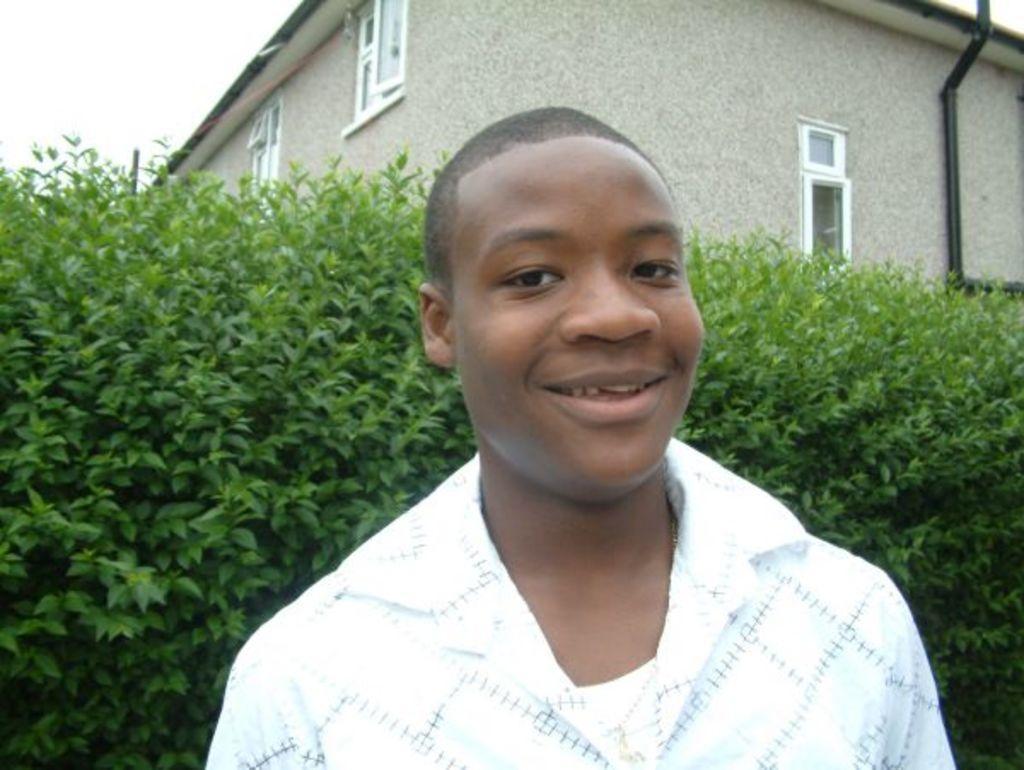In one or two sentences, can you explain what this image depicts? In this image I can see a person wearing white color shirt. Background I can see few trees in green color, building in gray color and sky in white color. 